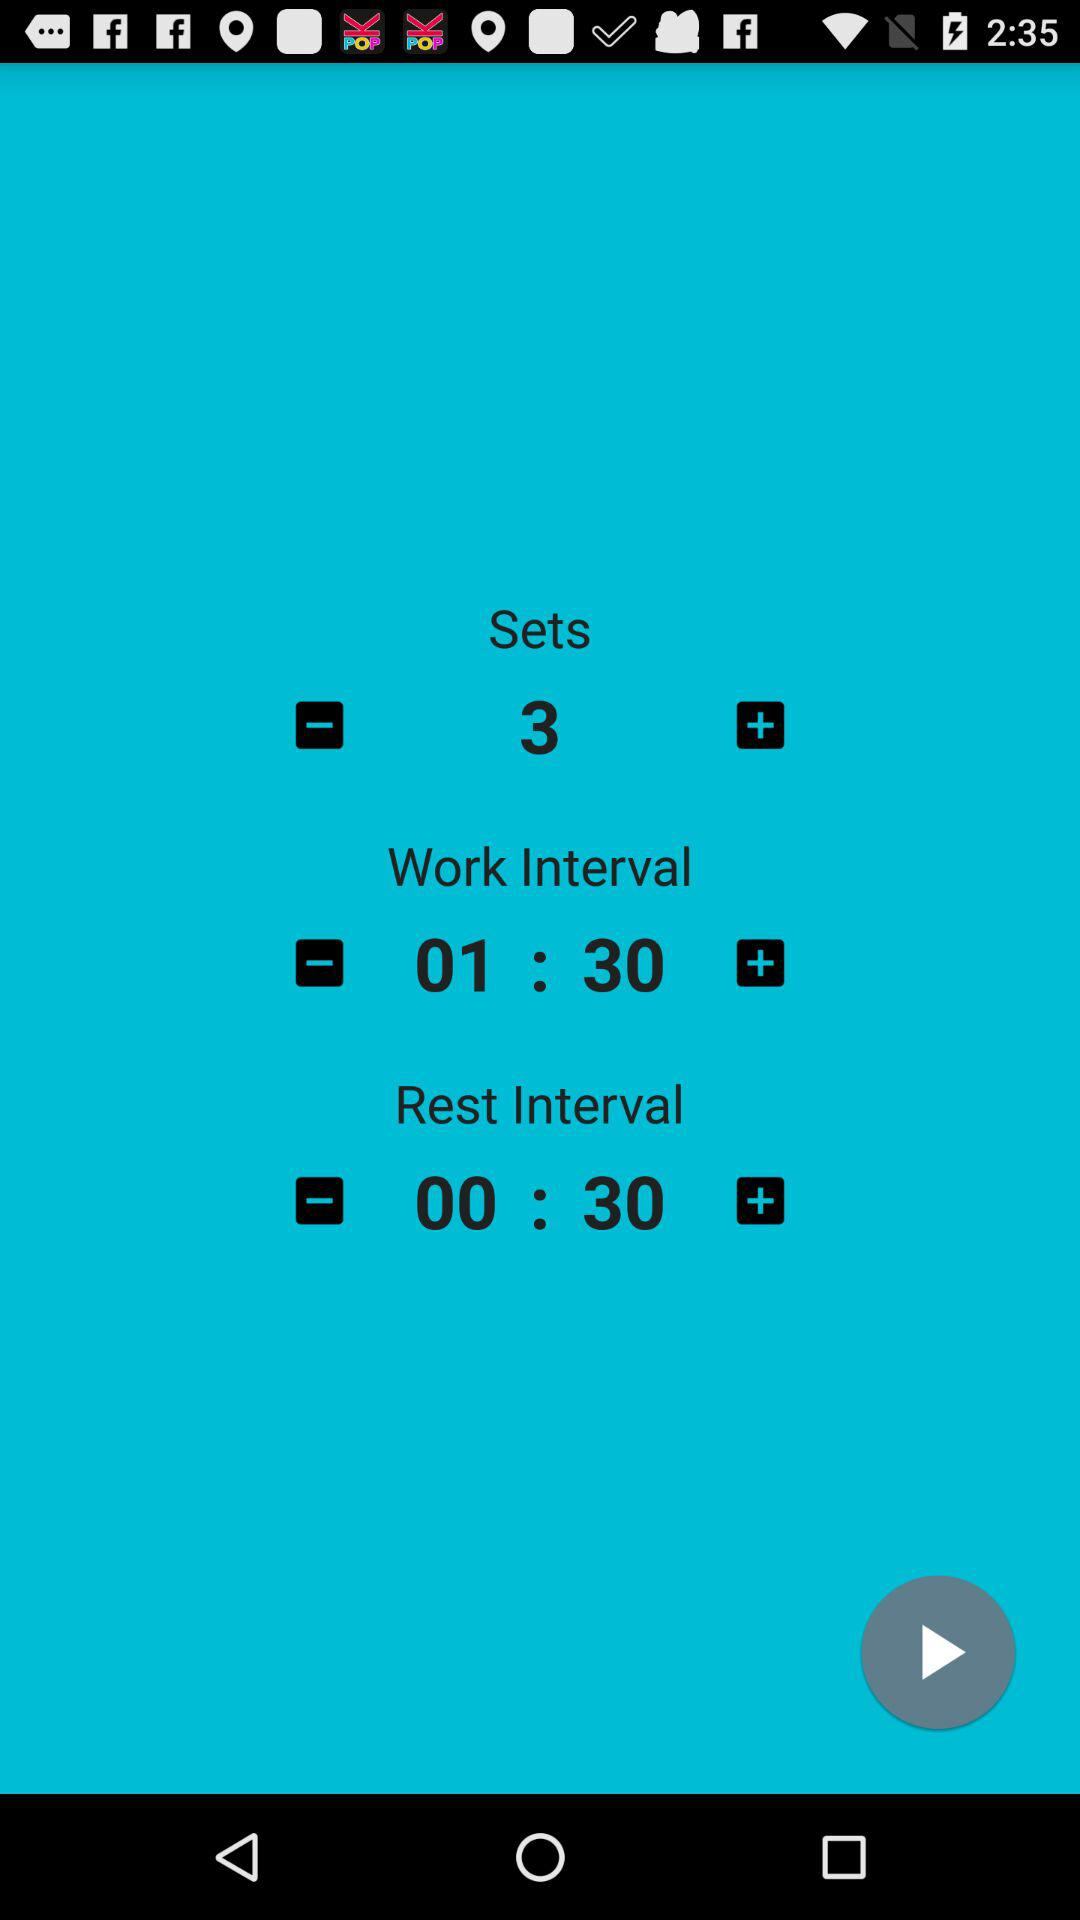How many sets are there in total?
Answer the question using a single word or phrase. 3 